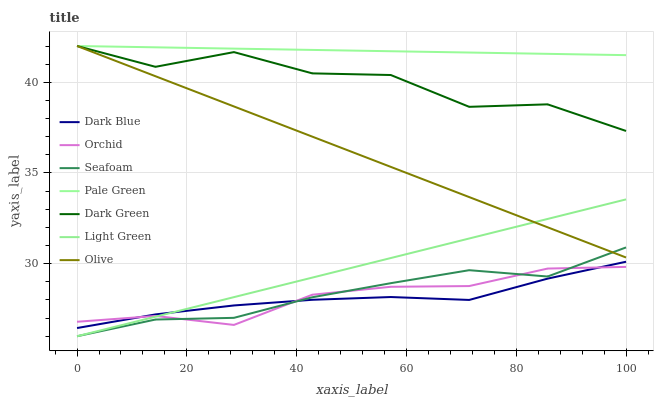Does Dark Blue have the minimum area under the curve?
Answer yes or no. Yes. Does Pale Green have the maximum area under the curve?
Answer yes or no. Yes. Does Pale Green have the minimum area under the curve?
Answer yes or no. No. Does Dark Blue have the maximum area under the curve?
Answer yes or no. No. Is Olive the smoothest?
Answer yes or no. Yes. Is Dark Green the roughest?
Answer yes or no. Yes. Is Dark Blue the smoothest?
Answer yes or no. No. Is Dark Blue the roughest?
Answer yes or no. No. Does Dark Blue have the lowest value?
Answer yes or no. No. Does Dark Green have the highest value?
Answer yes or no. Yes. Does Dark Blue have the highest value?
Answer yes or no. No. Is Light Green less than Dark Green?
Answer yes or no. Yes. Is Dark Green greater than Orchid?
Answer yes or no. Yes. Does Dark Blue intersect Light Green?
Answer yes or no. Yes. Is Dark Blue less than Light Green?
Answer yes or no. No. Is Dark Blue greater than Light Green?
Answer yes or no. No. Does Light Green intersect Dark Green?
Answer yes or no. No. 